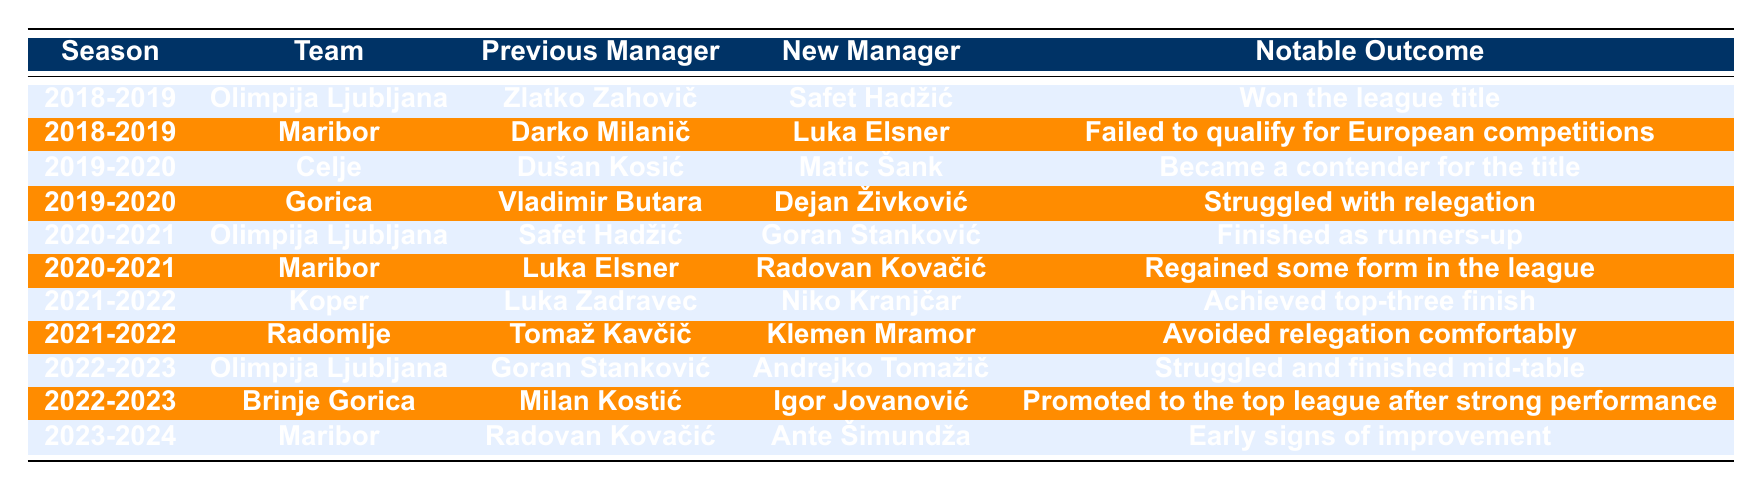What team had a managerial change in both 2018-2019 and 2020-2021? By reviewing the table, we see that Olimpija Ljubljana had managerial changes listed for both the 2018-2019 season and the 2020-2021 season.
Answer: Olimpija Ljubljana Which team changed managers most recently? The most recent entry in the table is for the 2023-2024 season, where Maribor changed their manager to Ante Šimundža.
Answer: Maribor Did any teams achieve a notable outcome after a managerial change in the 2019-2020 season? Looking at the notable outcomes in the 2019-2020 season, Celje became a contender for the title, indicating a positive outcome after their managerial change.
Answer: Yes How many times did Olimpija Ljubljana change managers in the last 5 seasons? The table indicates that Olimpija Ljubljana changed managers three times: in 2018-2019, 2020-2021, and 2022-2023.
Answer: Three times Was there any team that won a league title after a managerial change? According to the table, Olimpija Ljubljana won the league title in the 2018-2019 season after their managerial change.
Answer: Yes Which team avoided relegation comfortably in the 2021-2022 season? The table shows that Radomlje, after changing their manager to Klemen Mramor, avoided relegation comfortably during the 2021-2022 season.
Answer: Radomlje How many managerial changes did Maribor experience over the table's 5-season span? By checking the table, Maribor had three managerial changes in the seasons: 2018-2019, 2020-2021, and 2023-2024.
Answer: Three changes What was the notable outcome for Gorica in the 2019-2020 season? The outcome listed for Gorica in the 2019-2020 season indicates that they struggled with relegation after their managerial change.
Answer: Struggled with relegation Which team had two managerial changes between 2018-2019 and 2020-2021 seasons? The table shows that Maribor changed their manager in both the 2018-2019 and 2020-2021 seasons, indicating two managerial changes in that period.
Answer: Maribor What is the average count of managerial changes per team listed in the table? There are 10 managerial changes across 9 different teams, so the average is 10/9, which is approximately 1.11 (or rounded down to 1 if considering whole changes).
Answer: Approximately 1 